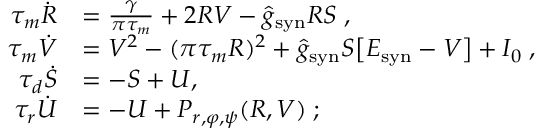<formula> <loc_0><loc_0><loc_500><loc_500>\begin{array} { r l } { \tau _ { m } \dot { R } } & { = \frac { \gamma } { \pi \tau _ { m } } + 2 R V - \hat { g } _ { s y n } R S \, , } \\ { \tau _ { m } \dot { V } } & { = V ^ { 2 } - ( \pi \tau _ { m } R ) ^ { 2 } + \hat { g } _ { s y n } S \left [ E _ { s y n } - V \right ] + I _ { 0 } \, , } \\ { \tau _ { d } \dot { S } } & { = - S + U , \, } \\ { \tau _ { r } \dot { U } } & { = - U + P _ { r , \varphi , \psi } ( R , V ) \, ; } \end{array}</formula> 